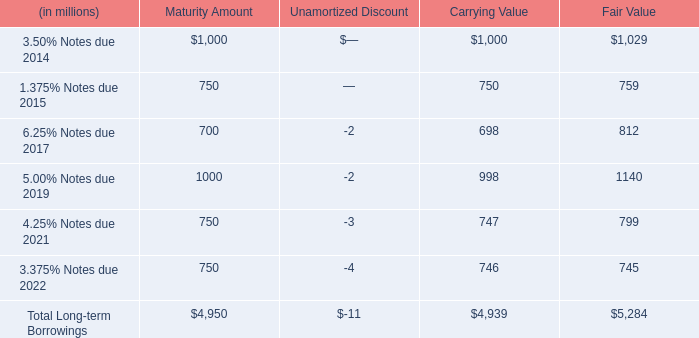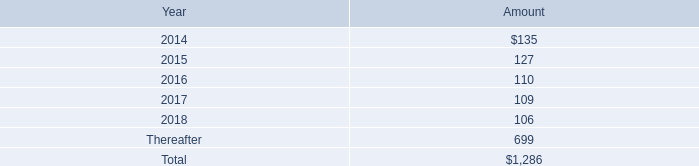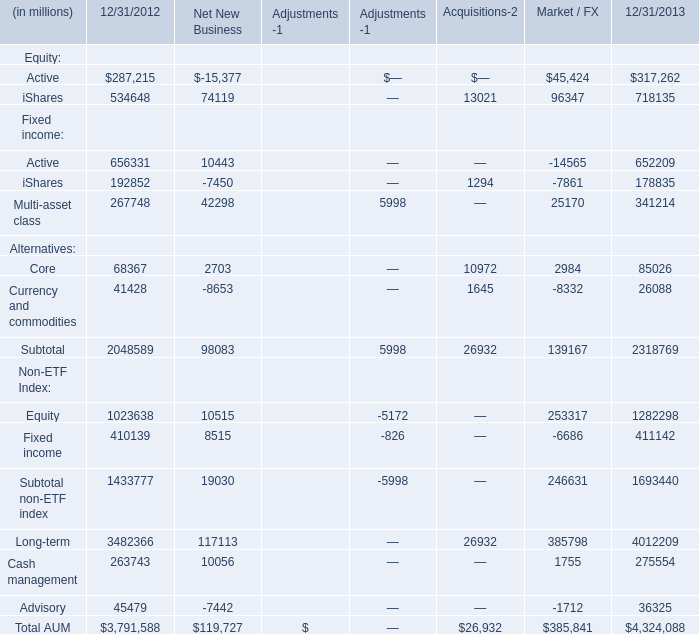what is the annual interest expense related to '2015 notes' , in millions? 
Computations: (750 * 1.375%)
Answer: 10.3125. 